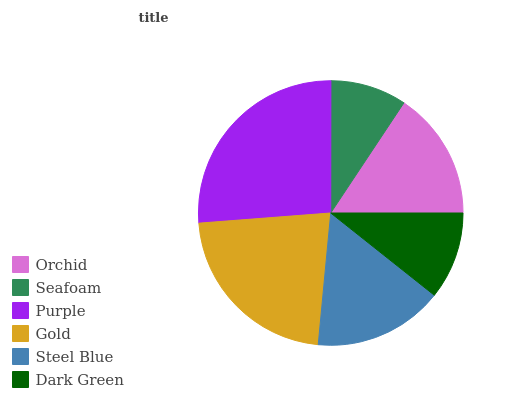Is Seafoam the minimum?
Answer yes or no. Yes. Is Purple the maximum?
Answer yes or no. Yes. Is Purple the minimum?
Answer yes or no. No. Is Seafoam the maximum?
Answer yes or no. No. Is Purple greater than Seafoam?
Answer yes or no. Yes. Is Seafoam less than Purple?
Answer yes or no. Yes. Is Seafoam greater than Purple?
Answer yes or no. No. Is Purple less than Seafoam?
Answer yes or no. No. Is Steel Blue the high median?
Answer yes or no. Yes. Is Orchid the low median?
Answer yes or no. Yes. Is Orchid the high median?
Answer yes or no. No. Is Gold the low median?
Answer yes or no. No. 